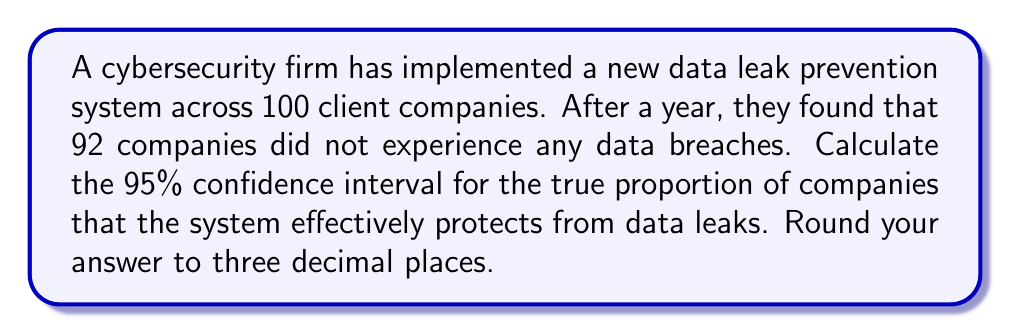Solve this math problem. To calculate the confidence interval for a proportion, we'll use the formula:

$$ p \pm z \sqrt{\frac{p(1-p)}{n}} $$

Where:
$p$ = sample proportion
$z$ = z-score for desired confidence level (1.96 for 95% confidence)
$n$ = sample size

Step 1: Calculate the sample proportion (p)
$p = \frac{92}{100} = 0.92$

Step 2: Determine the z-score for 95% confidence
$z = 1.96$

Step 3: Calculate the margin of error
$$ \text{Margin of Error} = 1.96 \sqrt{\frac{0.92(1-0.92)}{100}} $$
$$ = 1.96 \sqrt{\frac{0.92(0.08)}{100}} $$
$$ = 1.96 \sqrt{0.000736} $$
$$ = 1.96 (0.027129) $$
$$ = 0.053173 $$

Step 4: Calculate the confidence interval
Lower bound: $0.92 - 0.053173 = 0.866827$
Upper bound: $0.92 + 0.053173 = 0.973173$

Step 5: Round to three decimal places
Lower bound: $0.867$
Upper bound: $0.973$
Answer: (0.867, 0.973) 